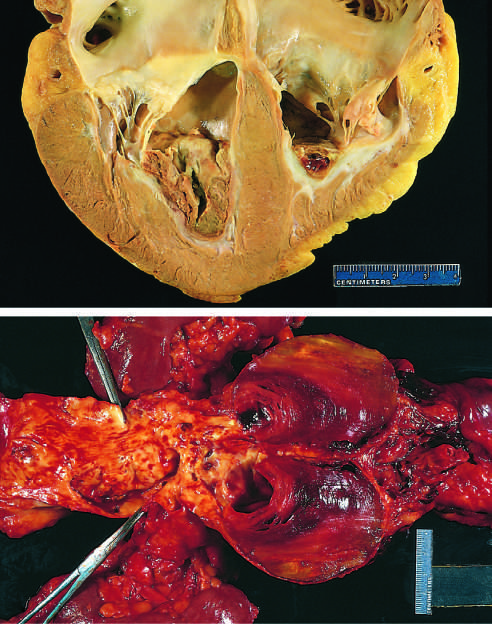what are super-imposed on advanced atherosclerotic lesions of the more proximal aorta (left side of photograph)?
Answer the question using a single word or phrase. Friable mural thrombi 